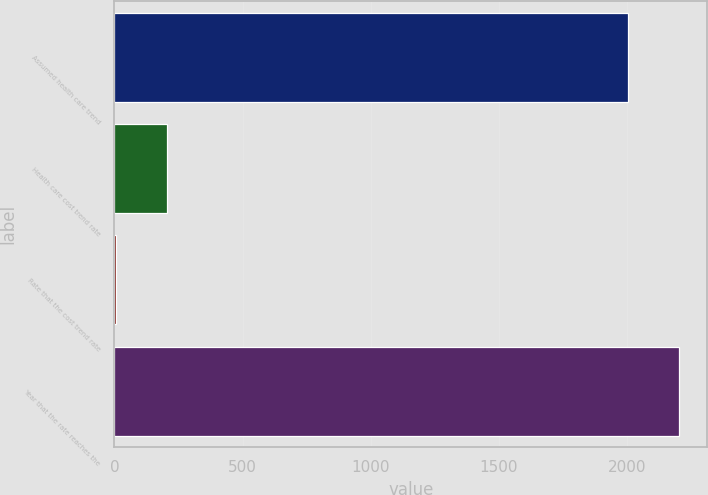Convert chart to OTSL. <chart><loc_0><loc_0><loc_500><loc_500><bar_chart><fcel>Assumed health care trend<fcel>Health care cost trend rate<fcel>Rate that the cost trend rate<fcel>Year that the rate reaches the<nl><fcel>2003<fcel>205.3<fcel>5<fcel>2203.3<nl></chart> 